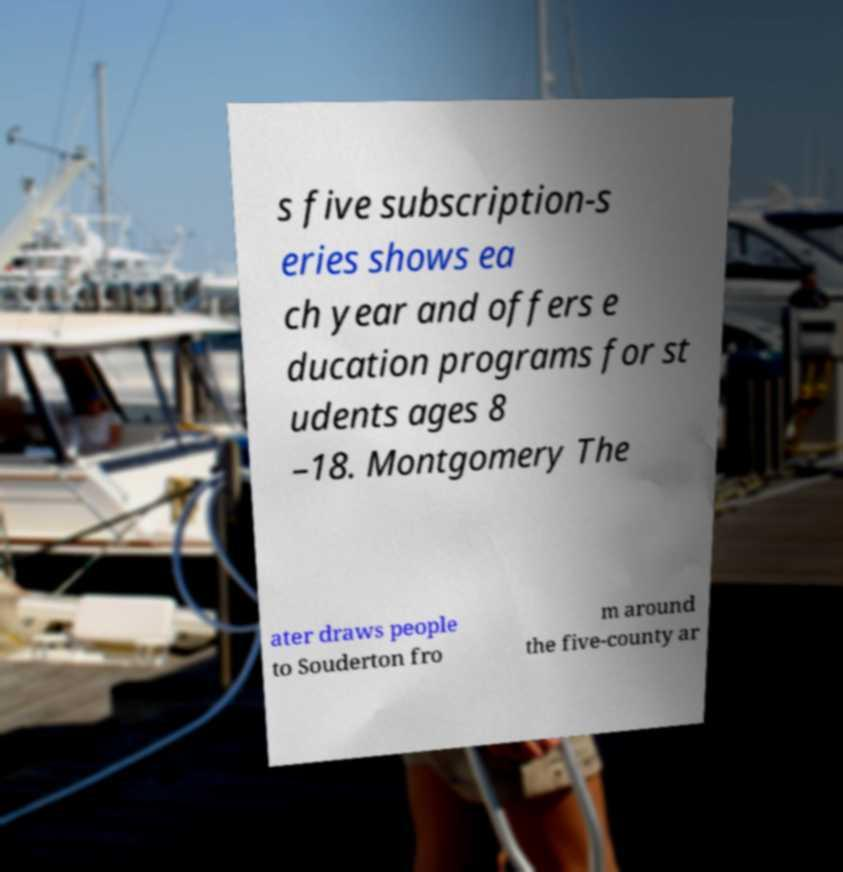There's text embedded in this image that I need extracted. Can you transcribe it verbatim? s five subscription-s eries shows ea ch year and offers e ducation programs for st udents ages 8 –18. Montgomery The ater draws people to Souderton fro m around the five-county ar 